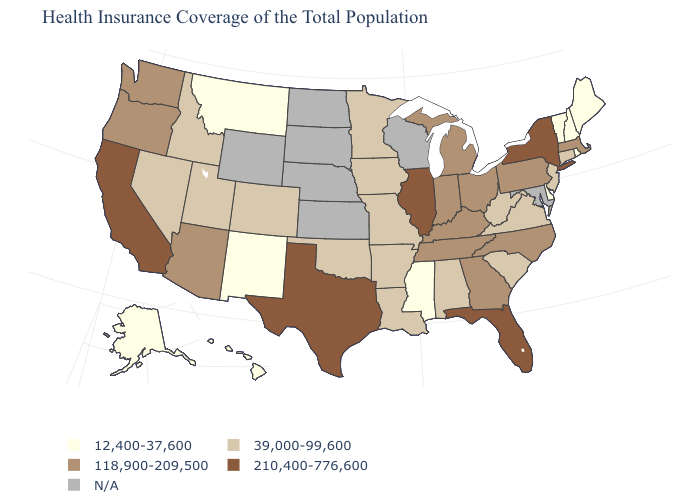What is the highest value in the MidWest ?
Quick response, please. 210,400-776,600. Does the map have missing data?
Give a very brief answer. Yes. Among the states that border North Dakota , which have the lowest value?
Concise answer only. Montana. Name the states that have a value in the range 39,000-99,600?
Answer briefly. Alabama, Arkansas, Colorado, Connecticut, Idaho, Iowa, Louisiana, Minnesota, Missouri, Nevada, New Jersey, Oklahoma, South Carolina, Utah, Virginia, West Virginia. Among the states that border North Dakota , which have the lowest value?
Keep it brief. Montana. What is the value of Minnesota?
Keep it brief. 39,000-99,600. Name the states that have a value in the range 118,900-209,500?
Be succinct. Arizona, Georgia, Indiana, Kentucky, Massachusetts, Michigan, North Carolina, Ohio, Oregon, Pennsylvania, Tennessee, Washington. Does New York have the highest value in the Northeast?
Be succinct. Yes. What is the value of Rhode Island?
Answer briefly. 12,400-37,600. Name the states that have a value in the range 39,000-99,600?
Keep it brief. Alabama, Arkansas, Colorado, Connecticut, Idaho, Iowa, Louisiana, Minnesota, Missouri, Nevada, New Jersey, Oklahoma, South Carolina, Utah, Virginia, West Virginia. What is the value of Colorado?
Answer briefly. 39,000-99,600. Among the states that border Ohio , which have the highest value?
Quick response, please. Indiana, Kentucky, Michigan, Pennsylvania. Does Florida have the highest value in the USA?
Quick response, please. Yes. 